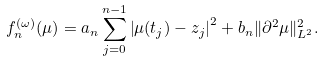<formula> <loc_0><loc_0><loc_500><loc_500>f _ { n } ^ { ( \omega ) } ( \mu ) = a _ { n } \sum _ { j = 0 } ^ { n - 1 } \left | \mu ( t _ { j } ) - z _ { j } \right | ^ { 2 } + b _ { n } \| \partial ^ { 2 } \mu \| ^ { 2 } _ { L ^ { 2 } } .</formula> 